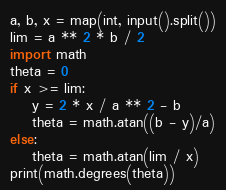Convert code to text. <code><loc_0><loc_0><loc_500><loc_500><_Python_>a, b, x = map(int, input().split())
lim = a ** 2 * b / 2
import math
theta = 0
if x >= lim:
    y = 2 * x / a ** 2 - b
    theta = math.atan((b - y)/a)
else:
    theta = math.atan(lim / x)
print(math.degrees(theta))
</code> 